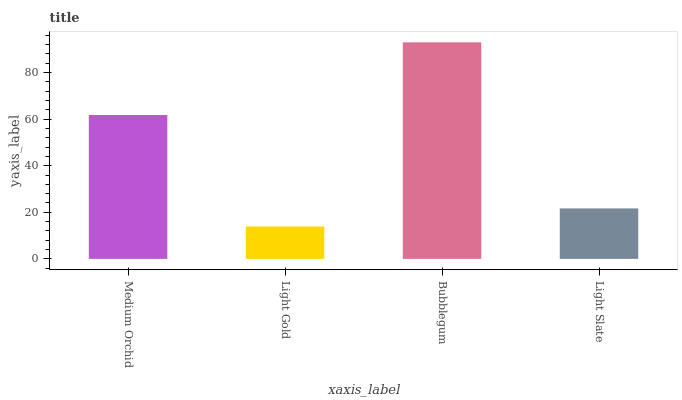Is Light Gold the minimum?
Answer yes or no. Yes. Is Bubblegum the maximum?
Answer yes or no. Yes. Is Bubblegum the minimum?
Answer yes or no. No. Is Light Gold the maximum?
Answer yes or no. No. Is Bubblegum greater than Light Gold?
Answer yes or no. Yes. Is Light Gold less than Bubblegum?
Answer yes or no. Yes. Is Light Gold greater than Bubblegum?
Answer yes or no. No. Is Bubblegum less than Light Gold?
Answer yes or no. No. Is Medium Orchid the high median?
Answer yes or no. Yes. Is Light Slate the low median?
Answer yes or no. Yes. Is Bubblegum the high median?
Answer yes or no. No. Is Light Gold the low median?
Answer yes or no. No. 